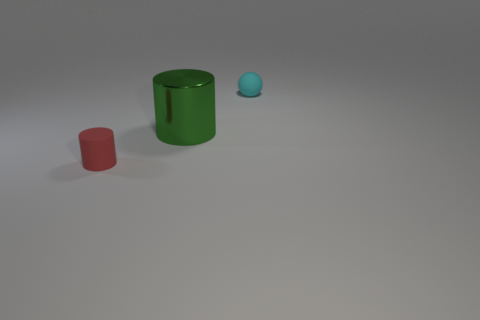Are there any small red things in front of the green metal cylinder?
Offer a very short reply. Yes. There is a red rubber cylinder; is it the same size as the rubber object behind the small red cylinder?
Your response must be concise. Yes. What number of other objects are there of the same material as the sphere?
Provide a succinct answer. 1. Is the size of the cylinder in front of the big green thing the same as the cyan ball behind the large green thing?
Offer a very short reply. Yes. There is a cyan object that is made of the same material as the tiny red cylinder; what shape is it?
Your response must be concise. Sphere. Is there anything else that is the same shape as the cyan rubber object?
Provide a succinct answer. No. There is a rubber thing right of the tiny object that is in front of the tiny cyan matte sphere behind the red thing; what color is it?
Provide a succinct answer. Cyan. Is the number of cyan matte objects that are to the left of the tiny matte cylinder less than the number of tiny cylinders that are behind the large metal object?
Offer a very short reply. No. Is the shape of the small red thing the same as the big metallic thing?
Keep it short and to the point. Yes. How many rubber cylinders are the same size as the sphere?
Keep it short and to the point. 1. 